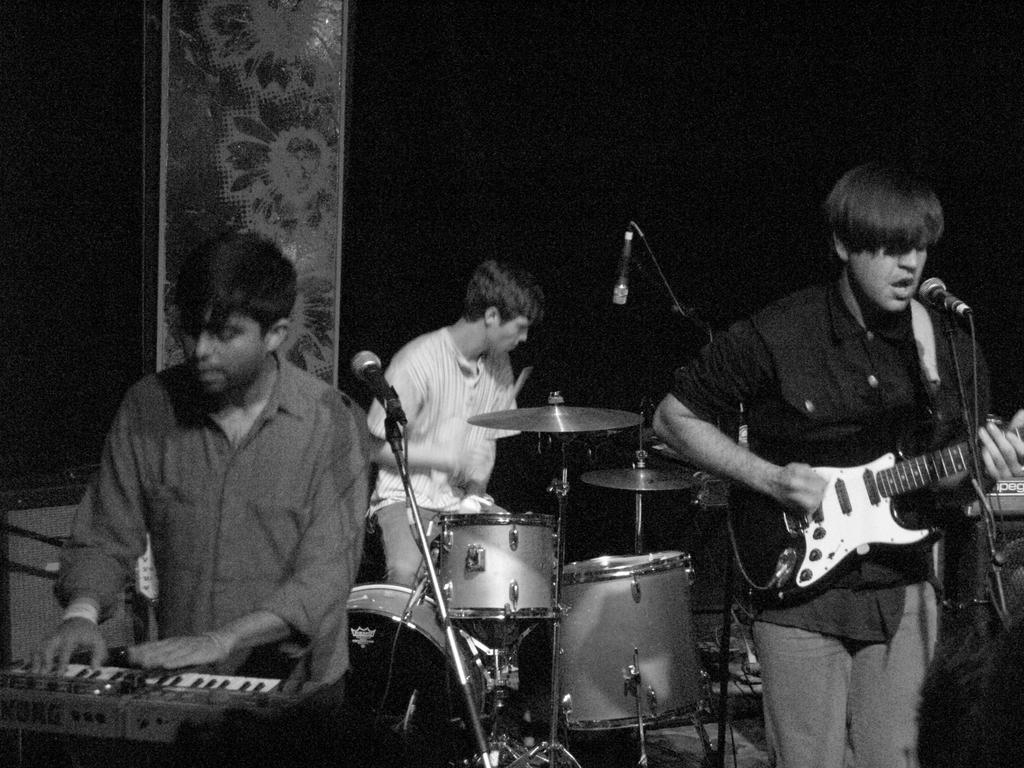How many people are in the image? There is a group of persons in the image. What are the persons in the image doing? The persons are playing musical instruments. What color is the sheet in the background of the image? There is a black color sheet in the background of the image. Where is the faucet located in the image? There is no faucet present in the image. What type of linen is draped over the instruments in the image? There is no linen draped over the instruments in the image. 